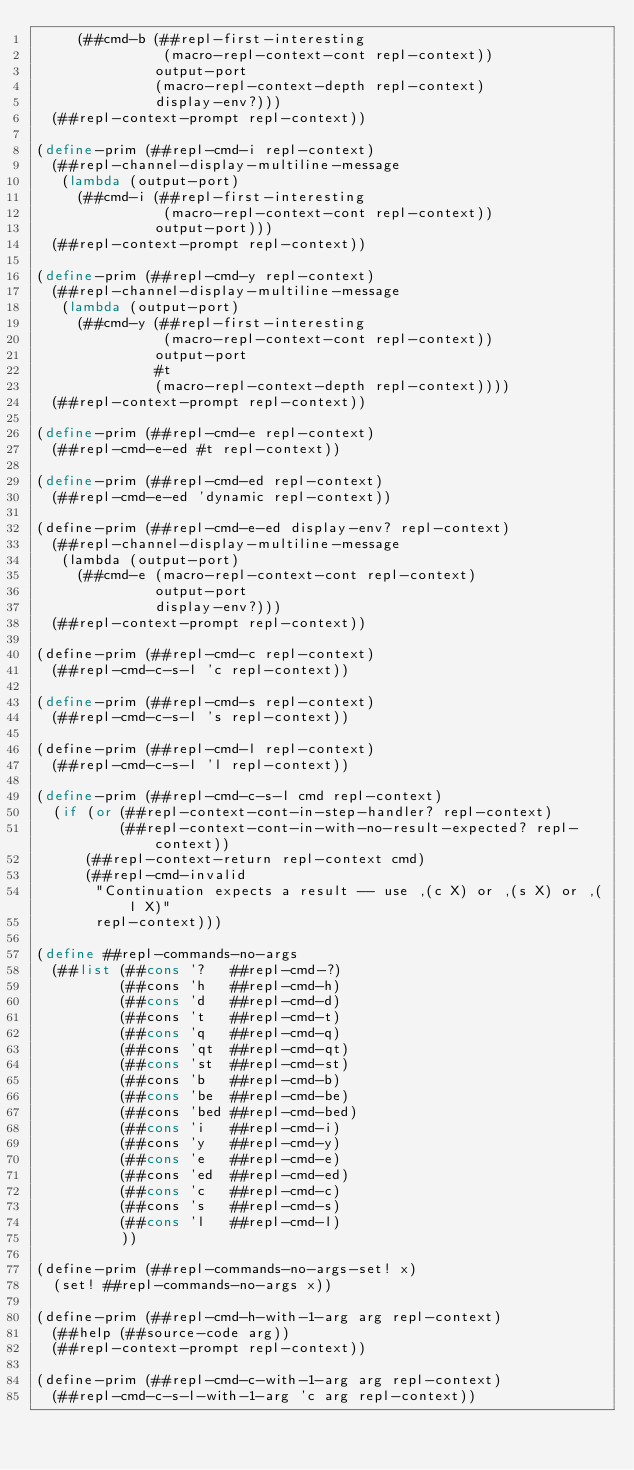Convert code to text. <code><loc_0><loc_0><loc_500><loc_500><_Scheme_>     (##cmd-b (##repl-first-interesting
               (macro-repl-context-cont repl-context))
              output-port
              (macro-repl-context-depth repl-context)
              display-env?)))
  (##repl-context-prompt repl-context))

(define-prim (##repl-cmd-i repl-context)
  (##repl-channel-display-multiline-message
   (lambda (output-port)
     (##cmd-i (##repl-first-interesting
               (macro-repl-context-cont repl-context))
              output-port)))
  (##repl-context-prompt repl-context))

(define-prim (##repl-cmd-y repl-context)
  (##repl-channel-display-multiline-message
   (lambda (output-port)
     (##cmd-y (##repl-first-interesting
               (macro-repl-context-cont repl-context))
              output-port
              #t
              (macro-repl-context-depth repl-context))))
  (##repl-context-prompt repl-context))

(define-prim (##repl-cmd-e repl-context)
  (##repl-cmd-e-ed #t repl-context))

(define-prim (##repl-cmd-ed repl-context)
  (##repl-cmd-e-ed 'dynamic repl-context))

(define-prim (##repl-cmd-e-ed display-env? repl-context)
  (##repl-channel-display-multiline-message
   (lambda (output-port)
     (##cmd-e (macro-repl-context-cont repl-context)
              output-port
              display-env?)))
  (##repl-context-prompt repl-context))

(define-prim (##repl-cmd-c repl-context)
  (##repl-cmd-c-s-l 'c repl-context))

(define-prim (##repl-cmd-s repl-context)
  (##repl-cmd-c-s-l 's repl-context))

(define-prim (##repl-cmd-l repl-context)
  (##repl-cmd-c-s-l 'l repl-context))

(define-prim (##repl-cmd-c-s-l cmd repl-context)
  (if (or (##repl-context-cont-in-step-handler? repl-context)
          (##repl-context-cont-in-with-no-result-expected? repl-context))
      (##repl-context-return repl-context cmd)
      (##repl-cmd-invalid
       "Continuation expects a result -- use ,(c X) or ,(s X) or ,(l X)"
       repl-context)))

(define ##repl-commands-no-args
  (##list (##cons '?   ##repl-cmd-?)
          (##cons 'h   ##repl-cmd-h)
          (##cons 'd   ##repl-cmd-d)
          (##cons 't   ##repl-cmd-t)
          (##cons 'q   ##repl-cmd-q)
          (##cons 'qt  ##repl-cmd-qt)
          (##cons 'st  ##repl-cmd-st)
          (##cons 'b   ##repl-cmd-b)
          (##cons 'be  ##repl-cmd-be)
          (##cons 'bed ##repl-cmd-bed)
          (##cons 'i   ##repl-cmd-i)
          (##cons 'y   ##repl-cmd-y)
          (##cons 'e   ##repl-cmd-e)
          (##cons 'ed  ##repl-cmd-ed)
          (##cons 'c   ##repl-cmd-c)
          (##cons 's   ##repl-cmd-s)
          (##cons 'l   ##repl-cmd-l)
          ))

(define-prim (##repl-commands-no-args-set! x)
  (set! ##repl-commands-no-args x))

(define-prim (##repl-cmd-h-with-1-arg arg repl-context)
  (##help (##source-code arg))
  (##repl-context-prompt repl-context))

(define-prim (##repl-cmd-c-with-1-arg arg repl-context)
  (##repl-cmd-c-s-l-with-1-arg 'c arg repl-context))
</code> 